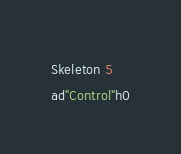Convert code to text. <code><loc_0><loc_0><loc_500><loc_500><_SML_>Skeleton 5
ad"Control"h0</code> 